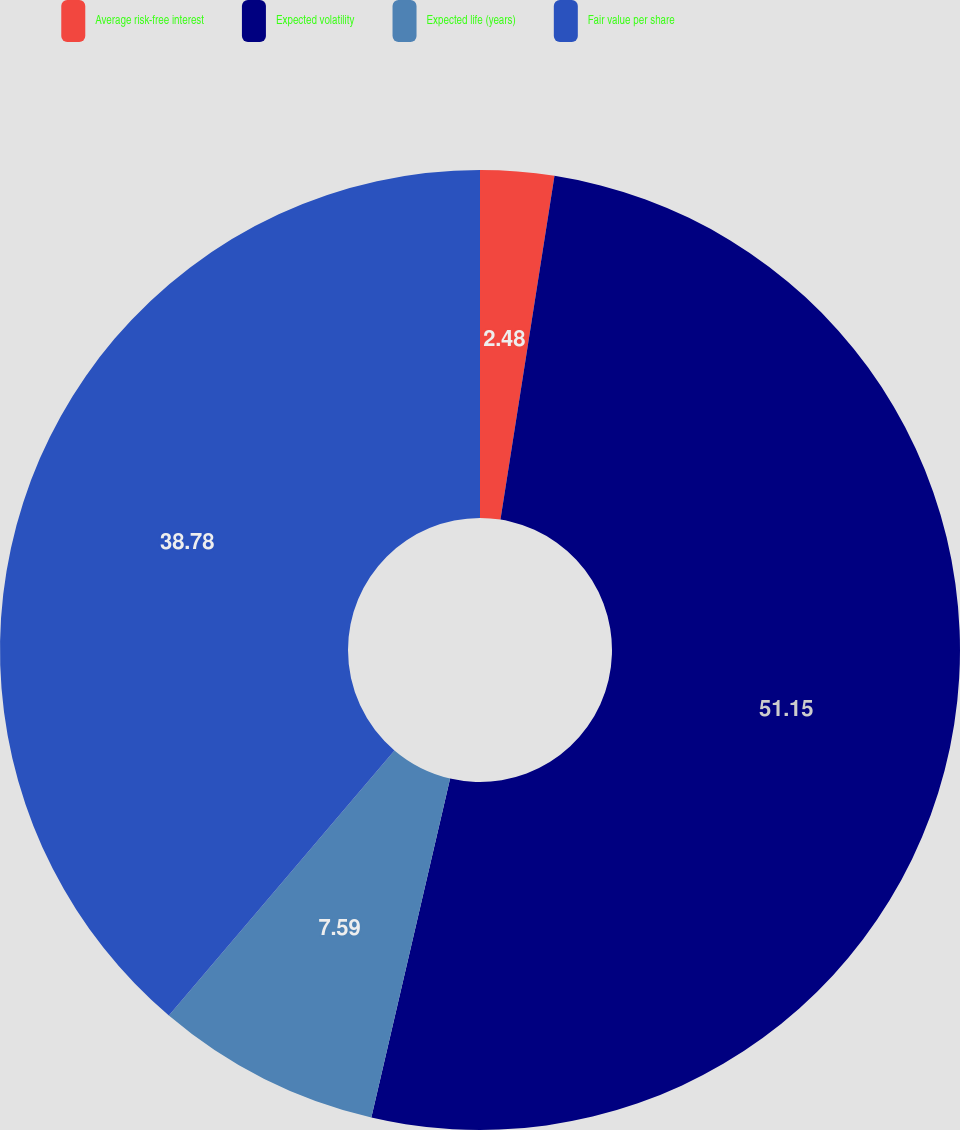Convert chart. <chart><loc_0><loc_0><loc_500><loc_500><pie_chart><fcel>Average risk-free interest<fcel>Expected volatility<fcel>Expected life (years)<fcel>Fair value per share<nl><fcel>2.48%<fcel>51.16%<fcel>7.59%<fcel>38.78%<nl></chart> 